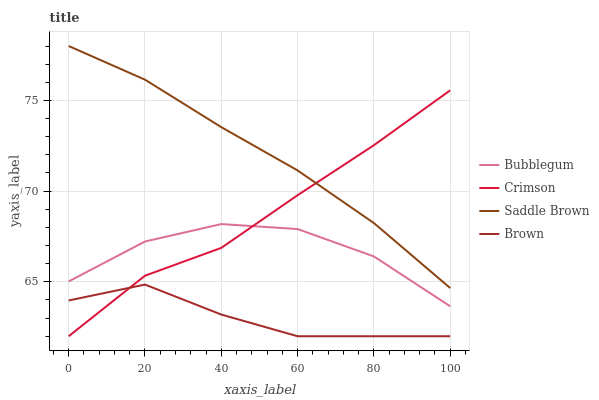Does Brown have the minimum area under the curve?
Answer yes or no. Yes. Does Saddle Brown have the maximum area under the curve?
Answer yes or no. Yes. Does Saddle Brown have the minimum area under the curve?
Answer yes or no. No. Does Brown have the maximum area under the curve?
Answer yes or no. No. Is Saddle Brown the smoothest?
Answer yes or no. Yes. Is Bubblegum the roughest?
Answer yes or no. Yes. Is Brown the smoothest?
Answer yes or no. No. Is Brown the roughest?
Answer yes or no. No. Does Crimson have the lowest value?
Answer yes or no. Yes. Does Saddle Brown have the lowest value?
Answer yes or no. No. Does Saddle Brown have the highest value?
Answer yes or no. Yes. Does Brown have the highest value?
Answer yes or no. No. Is Brown less than Bubblegum?
Answer yes or no. Yes. Is Saddle Brown greater than Brown?
Answer yes or no. Yes. Does Brown intersect Crimson?
Answer yes or no. Yes. Is Brown less than Crimson?
Answer yes or no. No. Is Brown greater than Crimson?
Answer yes or no. No. Does Brown intersect Bubblegum?
Answer yes or no. No. 